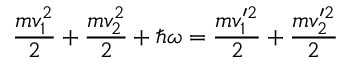Convert formula to latex. <formula><loc_0><loc_0><loc_500><loc_500>\frac { m v _ { 1 } ^ { 2 } } { 2 } + \frac { m v _ { 2 } ^ { 2 } } { 2 } + \hbar { \omega } = \frac { m v _ { 1 } ^ { \prime 2 } } { 2 } + \frac { m v _ { 2 } ^ { \prime 2 } } { 2 }</formula> 